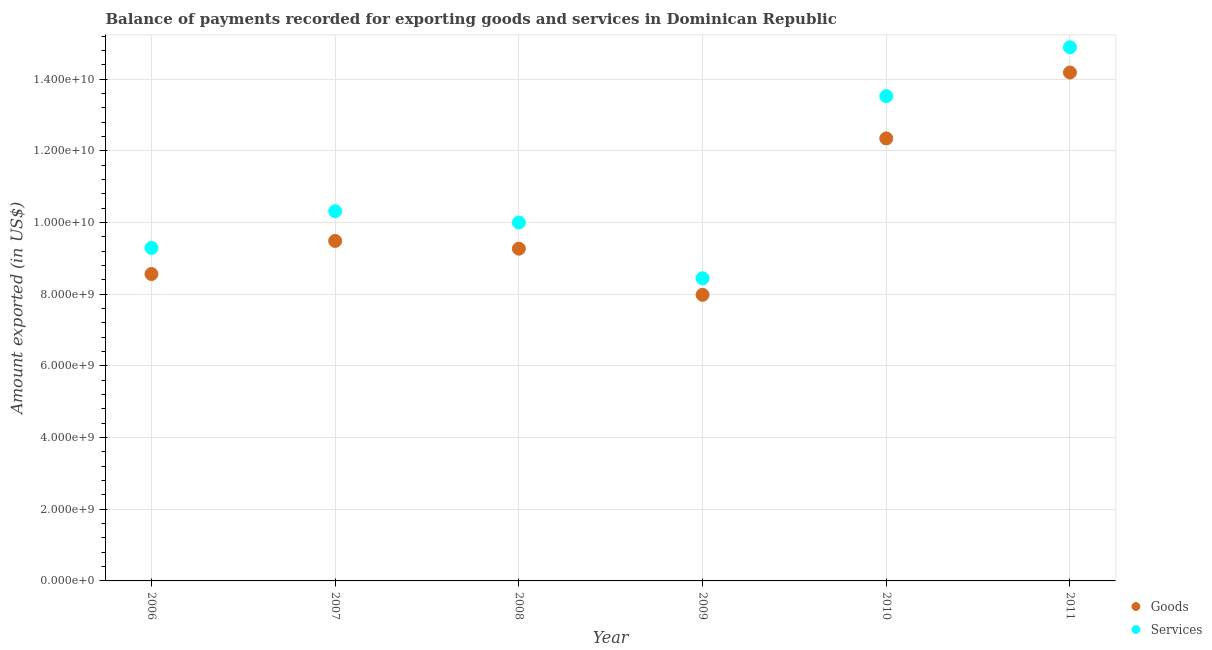Is the number of dotlines equal to the number of legend labels?
Your answer should be very brief. Yes. What is the amount of goods exported in 2006?
Your answer should be very brief. 8.56e+09. Across all years, what is the maximum amount of services exported?
Make the answer very short. 1.49e+1. Across all years, what is the minimum amount of goods exported?
Provide a short and direct response. 7.98e+09. In which year was the amount of services exported maximum?
Provide a short and direct response. 2011. What is the total amount of services exported in the graph?
Keep it short and to the point. 6.65e+1. What is the difference between the amount of goods exported in 2006 and that in 2011?
Offer a terse response. -5.62e+09. What is the difference between the amount of services exported in 2006 and the amount of goods exported in 2009?
Your answer should be very brief. 1.31e+09. What is the average amount of goods exported per year?
Give a very brief answer. 1.03e+1. In the year 2007, what is the difference between the amount of goods exported and amount of services exported?
Give a very brief answer. -8.29e+08. In how many years, is the amount of services exported greater than 4800000000 US$?
Make the answer very short. 6. What is the ratio of the amount of services exported in 2006 to that in 2009?
Provide a short and direct response. 1.1. Is the difference between the amount of goods exported in 2009 and 2010 greater than the difference between the amount of services exported in 2009 and 2010?
Offer a terse response. Yes. What is the difference between the highest and the second highest amount of goods exported?
Your answer should be compact. 1.84e+09. What is the difference between the highest and the lowest amount of services exported?
Ensure brevity in your answer.  6.45e+09. In how many years, is the amount of services exported greater than the average amount of services exported taken over all years?
Your response must be concise. 2. Is the amount of services exported strictly greater than the amount of goods exported over the years?
Your response must be concise. Yes. Is the amount of services exported strictly less than the amount of goods exported over the years?
Offer a terse response. No. What is the difference between two consecutive major ticks on the Y-axis?
Ensure brevity in your answer.  2.00e+09. Are the values on the major ticks of Y-axis written in scientific E-notation?
Provide a short and direct response. Yes. Does the graph contain any zero values?
Offer a terse response. No. How are the legend labels stacked?
Offer a very short reply. Vertical. What is the title of the graph?
Offer a very short reply. Balance of payments recorded for exporting goods and services in Dominican Republic. What is the label or title of the Y-axis?
Make the answer very short. Amount exported (in US$). What is the Amount exported (in US$) of Goods in 2006?
Give a very brief answer. 8.56e+09. What is the Amount exported (in US$) in Services in 2006?
Give a very brief answer. 9.29e+09. What is the Amount exported (in US$) of Goods in 2007?
Make the answer very short. 9.49e+09. What is the Amount exported (in US$) of Services in 2007?
Your answer should be very brief. 1.03e+1. What is the Amount exported (in US$) in Goods in 2008?
Ensure brevity in your answer.  9.27e+09. What is the Amount exported (in US$) of Services in 2008?
Offer a very short reply. 1.00e+1. What is the Amount exported (in US$) of Goods in 2009?
Your response must be concise. 7.98e+09. What is the Amount exported (in US$) of Services in 2009?
Provide a short and direct response. 8.44e+09. What is the Amount exported (in US$) of Goods in 2010?
Keep it short and to the point. 1.23e+1. What is the Amount exported (in US$) in Services in 2010?
Make the answer very short. 1.35e+1. What is the Amount exported (in US$) in Goods in 2011?
Offer a terse response. 1.42e+1. What is the Amount exported (in US$) of Services in 2011?
Provide a succinct answer. 1.49e+1. Across all years, what is the maximum Amount exported (in US$) in Goods?
Make the answer very short. 1.42e+1. Across all years, what is the maximum Amount exported (in US$) of Services?
Ensure brevity in your answer.  1.49e+1. Across all years, what is the minimum Amount exported (in US$) of Goods?
Your answer should be compact. 7.98e+09. Across all years, what is the minimum Amount exported (in US$) of Services?
Provide a succinct answer. 8.44e+09. What is the total Amount exported (in US$) in Goods in the graph?
Offer a very short reply. 6.18e+1. What is the total Amount exported (in US$) in Services in the graph?
Provide a succinct answer. 6.65e+1. What is the difference between the Amount exported (in US$) in Goods in 2006 and that in 2007?
Provide a succinct answer. -9.23e+08. What is the difference between the Amount exported (in US$) of Services in 2006 and that in 2007?
Offer a very short reply. -1.02e+09. What is the difference between the Amount exported (in US$) of Goods in 2006 and that in 2008?
Your answer should be compact. -7.08e+08. What is the difference between the Amount exported (in US$) of Services in 2006 and that in 2008?
Offer a terse response. -7.08e+08. What is the difference between the Amount exported (in US$) in Goods in 2006 and that in 2009?
Offer a very short reply. 5.80e+08. What is the difference between the Amount exported (in US$) in Services in 2006 and that in 2009?
Give a very brief answer. 8.48e+08. What is the difference between the Amount exported (in US$) in Goods in 2006 and that in 2010?
Offer a very short reply. -3.78e+09. What is the difference between the Amount exported (in US$) of Services in 2006 and that in 2010?
Keep it short and to the point. -4.23e+09. What is the difference between the Amount exported (in US$) in Goods in 2006 and that in 2011?
Your answer should be compact. -5.62e+09. What is the difference between the Amount exported (in US$) of Services in 2006 and that in 2011?
Ensure brevity in your answer.  -5.60e+09. What is the difference between the Amount exported (in US$) of Goods in 2007 and that in 2008?
Make the answer very short. 2.16e+08. What is the difference between the Amount exported (in US$) of Services in 2007 and that in 2008?
Your response must be concise. 3.16e+08. What is the difference between the Amount exported (in US$) in Goods in 2007 and that in 2009?
Your answer should be compact. 1.50e+09. What is the difference between the Amount exported (in US$) of Services in 2007 and that in 2009?
Offer a terse response. 1.87e+09. What is the difference between the Amount exported (in US$) in Goods in 2007 and that in 2010?
Provide a succinct answer. -2.86e+09. What is the difference between the Amount exported (in US$) in Services in 2007 and that in 2010?
Your response must be concise. -3.21e+09. What is the difference between the Amount exported (in US$) in Goods in 2007 and that in 2011?
Make the answer very short. -4.70e+09. What is the difference between the Amount exported (in US$) in Services in 2007 and that in 2011?
Your answer should be compact. -4.58e+09. What is the difference between the Amount exported (in US$) of Goods in 2008 and that in 2009?
Offer a very short reply. 1.29e+09. What is the difference between the Amount exported (in US$) of Services in 2008 and that in 2009?
Your answer should be very brief. 1.56e+09. What is the difference between the Amount exported (in US$) of Goods in 2008 and that in 2010?
Make the answer very short. -3.08e+09. What is the difference between the Amount exported (in US$) in Services in 2008 and that in 2010?
Offer a very short reply. -3.53e+09. What is the difference between the Amount exported (in US$) of Goods in 2008 and that in 2011?
Offer a terse response. -4.91e+09. What is the difference between the Amount exported (in US$) of Services in 2008 and that in 2011?
Make the answer very short. -4.89e+09. What is the difference between the Amount exported (in US$) of Goods in 2009 and that in 2010?
Your response must be concise. -4.36e+09. What is the difference between the Amount exported (in US$) in Services in 2009 and that in 2010?
Your answer should be compact. -5.08e+09. What is the difference between the Amount exported (in US$) of Goods in 2009 and that in 2011?
Provide a short and direct response. -6.20e+09. What is the difference between the Amount exported (in US$) of Services in 2009 and that in 2011?
Make the answer very short. -6.45e+09. What is the difference between the Amount exported (in US$) in Goods in 2010 and that in 2011?
Make the answer very short. -1.84e+09. What is the difference between the Amount exported (in US$) in Services in 2010 and that in 2011?
Provide a succinct answer. -1.36e+09. What is the difference between the Amount exported (in US$) of Goods in 2006 and the Amount exported (in US$) of Services in 2007?
Your answer should be very brief. -1.75e+09. What is the difference between the Amount exported (in US$) of Goods in 2006 and the Amount exported (in US$) of Services in 2008?
Provide a succinct answer. -1.44e+09. What is the difference between the Amount exported (in US$) of Goods in 2006 and the Amount exported (in US$) of Services in 2009?
Make the answer very short. 1.19e+08. What is the difference between the Amount exported (in US$) in Goods in 2006 and the Amount exported (in US$) in Services in 2010?
Your answer should be very brief. -4.96e+09. What is the difference between the Amount exported (in US$) of Goods in 2006 and the Amount exported (in US$) of Services in 2011?
Offer a terse response. -6.33e+09. What is the difference between the Amount exported (in US$) in Goods in 2007 and the Amount exported (in US$) in Services in 2008?
Offer a terse response. -5.13e+08. What is the difference between the Amount exported (in US$) of Goods in 2007 and the Amount exported (in US$) of Services in 2009?
Your answer should be very brief. 1.04e+09. What is the difference between the Amount exported (in US$) of Goods in 2007 and the Amount exported (in US$) of Services in 2010?
Give a very brief answer. -4.04e+09. What is the difference between the Amount exported (in US$) in Goods in 2007 and the Amount exported (in US$) in Services in 2011?
Offer a terse response. -5.40e+09. What is the difference between the Amount exported (in US$) of Goods in 2008 and the Amount exported (in US$) of Services in 2009?
Offer a very short reply. 8.26e+08. What is the difference between the Amount exported (in US$) in Goods in 2008 and the Amount exported (in US$) in Services in 2010?
Provide a short and direct response. -4.26e+09. What is the difference between the Amount exported (in US$) of Goods in 2008 and the Amount exported (in US$) of Services in 2011?
Your answer should be compact. -5.62e+09. What is the difference between the Amount exported (in US$) in Goods in 2009 and the Amount exported (in US$) in Services in 2010?
Your answer should be very brief. -5.54e+09. What is the difference between the Amount exported (in US$) in Goods in 2009 and the Amount exported (in US$) in Services in 2011?
Keep it short and to the point. -6.91e+09. What is the difference between the Amount exported (in US$) in Goods in 2010 and the Amount exported (in US$) in Services in 2011?
Give a very brief answer. -2.54e+09. What is the average Amount exported (in US$) in Goods per year?
Keep it short and to the point. 1.03e+1. What is the average Amount exported (in US$) in Services per year?
Your answer should be very brief. 1.11e+1. In the year 2006, what is the difference between the Amount exported (in US$) in Goods and Amount exported (in US$) in Services?
Offer a very short reply. -7.29e+08. In the year 2007, what is the difference between the Amount exported (in US$) in Goods and Amount exported (in US$) in Services?
Keep it short and to the point. -8.29e+08. In the year 2008, what is the difference between the Amount exported (in US$) of Goods and Amount exported (in US$) of Services?
Make the answer very short. -7.29e+08. In the year 2009, what is the difference between the Amount exported (in US$) in Goods and Amount exported (in US$) in Services?
Give a very brief answer. -4.61e+08. In the year 2010, what is the difference between the Amount exported (in US$) of Goods and Amount exported (in US$) of Services?
Ensure brevity in your answer.  -1.18e+09. In the year 2011, what is the difference between the Amount exported (in US$) of Goods and Amount exported (in US$) of Services?
Your response must be concise. -7.05e+08. What is the ratio of the Amount exported (in US$) in Goods in 2006 to that in 2007?
Provide a short and direct response. 0.9. What is the ratio of the Amount exported (in US$) of Services in 2006 to that in 2007?
Make the answer very short. 0.9. What is the ratio of the Amount exported (in US$) in Goods in 2006 to that in 2008?
Give a very brief answer. 0.92. What is the ratio of the Amount exported (in US$) in Services in 2006 to that in 2008?
Give a very brief answer. 0.93. What is the ratio of the Amount exported (in US$) of Goods in 2006 to that in 2009?
Make the answer very short. 1.07. What is the ratio of the Amount exported (in US$) of Services in 2006 to that in 2009?
Ensure brevity in your answer.  1.1. What is the ratio of the Amount exported (in US$) of Goods in 2006 to that in 2010?
Give a very brief answer. 0.69. What is the ratio of the Amount exported (in US$) of Services in 2006 to that in 2010?
Keep it short and to the point. 0.69. What is the ratio of the Amount exported (in US$) in Goods in 2006 to that in 2011?
Your answer should be compact. 0.6. What is the ratio of the Amount exported (in US$) of Services in 2006 to that in 2011?
Keep it short and to the point. 0.62. What is the ratio of the Amount exported (in US$) of Goods in 2007 to that in 2008?
Your response must be concise. 1.02. What is the ratio of the Amount exported (in US$) in Services in 2007 to that in 2008?
Ensure brevity in your answer.  1.03. What is the ratio of the Amount exported (in US$) of Goods in 2007 to that in 2009?
Give a very brief answer. 1.19. What is the ratio of the Amount exported (in US$) in Services in 2007 to that in 2009?
Offer a very short reply. 1.22. What is the ratio of the Amount exported (in US$) of Goods in 2007 to that in 2010?
Provide a short and direct response. 0.77. What is the ratio of the Amount exported (in US$) of Services in 2007 to that in 2010?
Offer a very short reply. 0.76. What is the ratio of the Amount exported (in US$) of Goods in 2007 to that in 2011?
Your response must be concise. 0.67. What is the ratio of the Amount exported (in US$) of Services in 2007 to that in 2011?
Ensure brevity in your answer.  0.69. What is the ratio of the Amount exported (in US$) of Goods in 2008 to that in 2009?
Offer a very short reply. 1.16. What is the ratio of the Amount exported (in US$) of Services in 2008 to that in 2009?
Make the answer very short. 1.18. What is the ratio of the Amount exported (in US$) of Goods in 2008 to that in 2010?
Your answer should be very brief. 0.75. What is the ratio of the Amount exported (in US$) in Services in 2008 to that in 2010?
Ensure brevity in your answer.  0.74. What is the ratio of the Amount exported (in US$) in Goods in 2008 to that in 2011?
Ensure brevity in your answer.  0.65. What is the ratio of the Amount exported (in US$) of Services in 2008 to that in 2011?
Your response must be concise. 0.67. What is the ratio of the Amount exported (in US$) of Goods in 2009 to that in 2010?
Your answer should be compact. 0.65. What is the ratio of the Amount exported (in US$) in Services in 2009 to that in 2010?
Offer a terse response. 0.62. What is the ratio of the Amount exported (in US$) in Goods in 2009 to that in 2011?
Your answer should be compact. 0.56. What is the ratio of the Amount exported (in US$) in Services in 2009 to that in 2011?
Provide a short and direct response. 0.57. What is the ratio of the Amount exported (in US$) of Goods in 2010 to that in 2011?
Your response must be concise. 0.87. What is the ratio of the Amount exported (in US$) of Services in 2010 to that in 2011?
Keep it short and to the point. 0.91. What is the difference between the highest and the second highest Amount exported (in US$) of Goods?
Provide a short and direct response. 1.84e+09. What is the difference between the highest and the second highest Amount exported (in US$) of Services?
Your response must be concise. 1.36e+09. What is the difference between the highest and the lowest Amount exported (in US$) of Goods?
Your answer should be very brief. 6.20e+09. What is the difference between the highest and the lowest Amount exported (in US$) of Services?
Keep it short and to the point. 6.45e+09. 